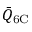<formula> <loc_0><loc_0><loc_500><loc_500>\bar { Q } _ { 6 C }</formula> 